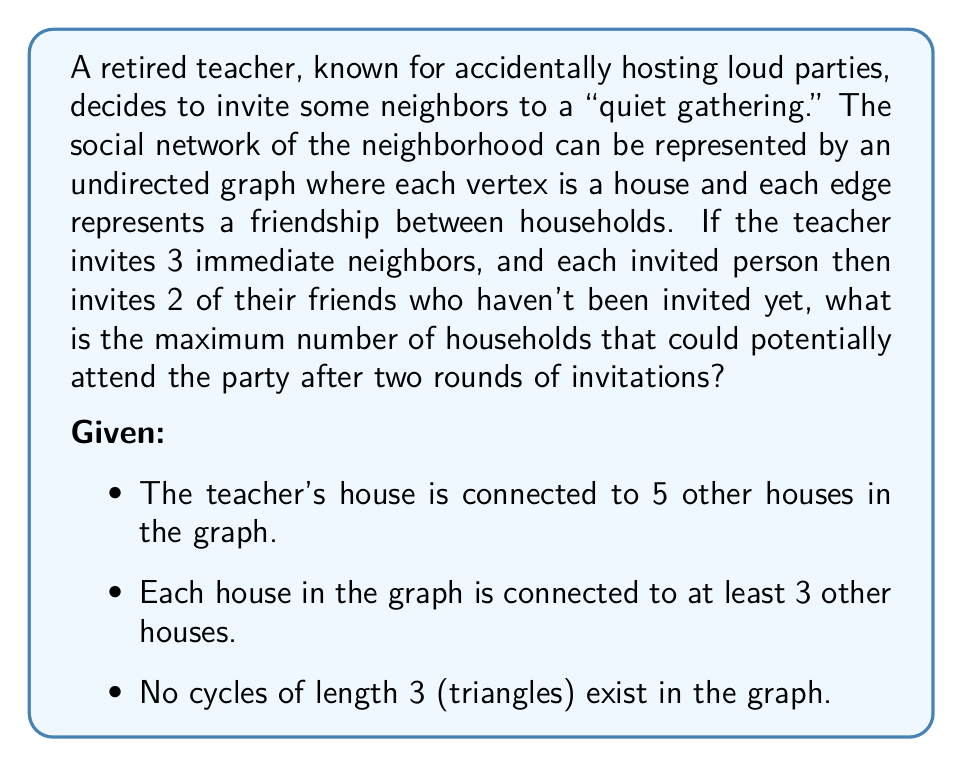Could you help me with this problem? Let's approach this step-by-step:

1) First, let's consider the initial invitations:
   - The teacher invites 3 immediate neighbors out of the 5 connected houses.

2) For the second round of invitations, each of these 3 invitees will invite 2 of their friends.
   - However, we need to ensure we don't count any house twice.

3) Let's consider the maximum possible new invitees for each of the 3 initial invitees:
   - Due to the no-triangle condition, none of the teacher's neighbors are connected to each other.
   - Each initial invitee is connected to the teacher and at least 2 other houses (as each house is connected to at least 3 others).
   - Therefore, each initial invitee can potentially invite 2 new houses.

4) Maximum new invitations in the second round:
   $$ 3 \text{ initial invitees} \times 2 \text{ new invitations each} = 6 \text{ new invitations} $$

5) Total potential attendees:
   - Teacher's house: 1
   - First round invitees: 3
   - Second round invitees: 6
   
   $$ \text{Total} = 1 + 3 + 6 = 10 \text{ households} $$
Answer: The maximum number of households that could potentially attend the party after two rounds of invitations is 10. 